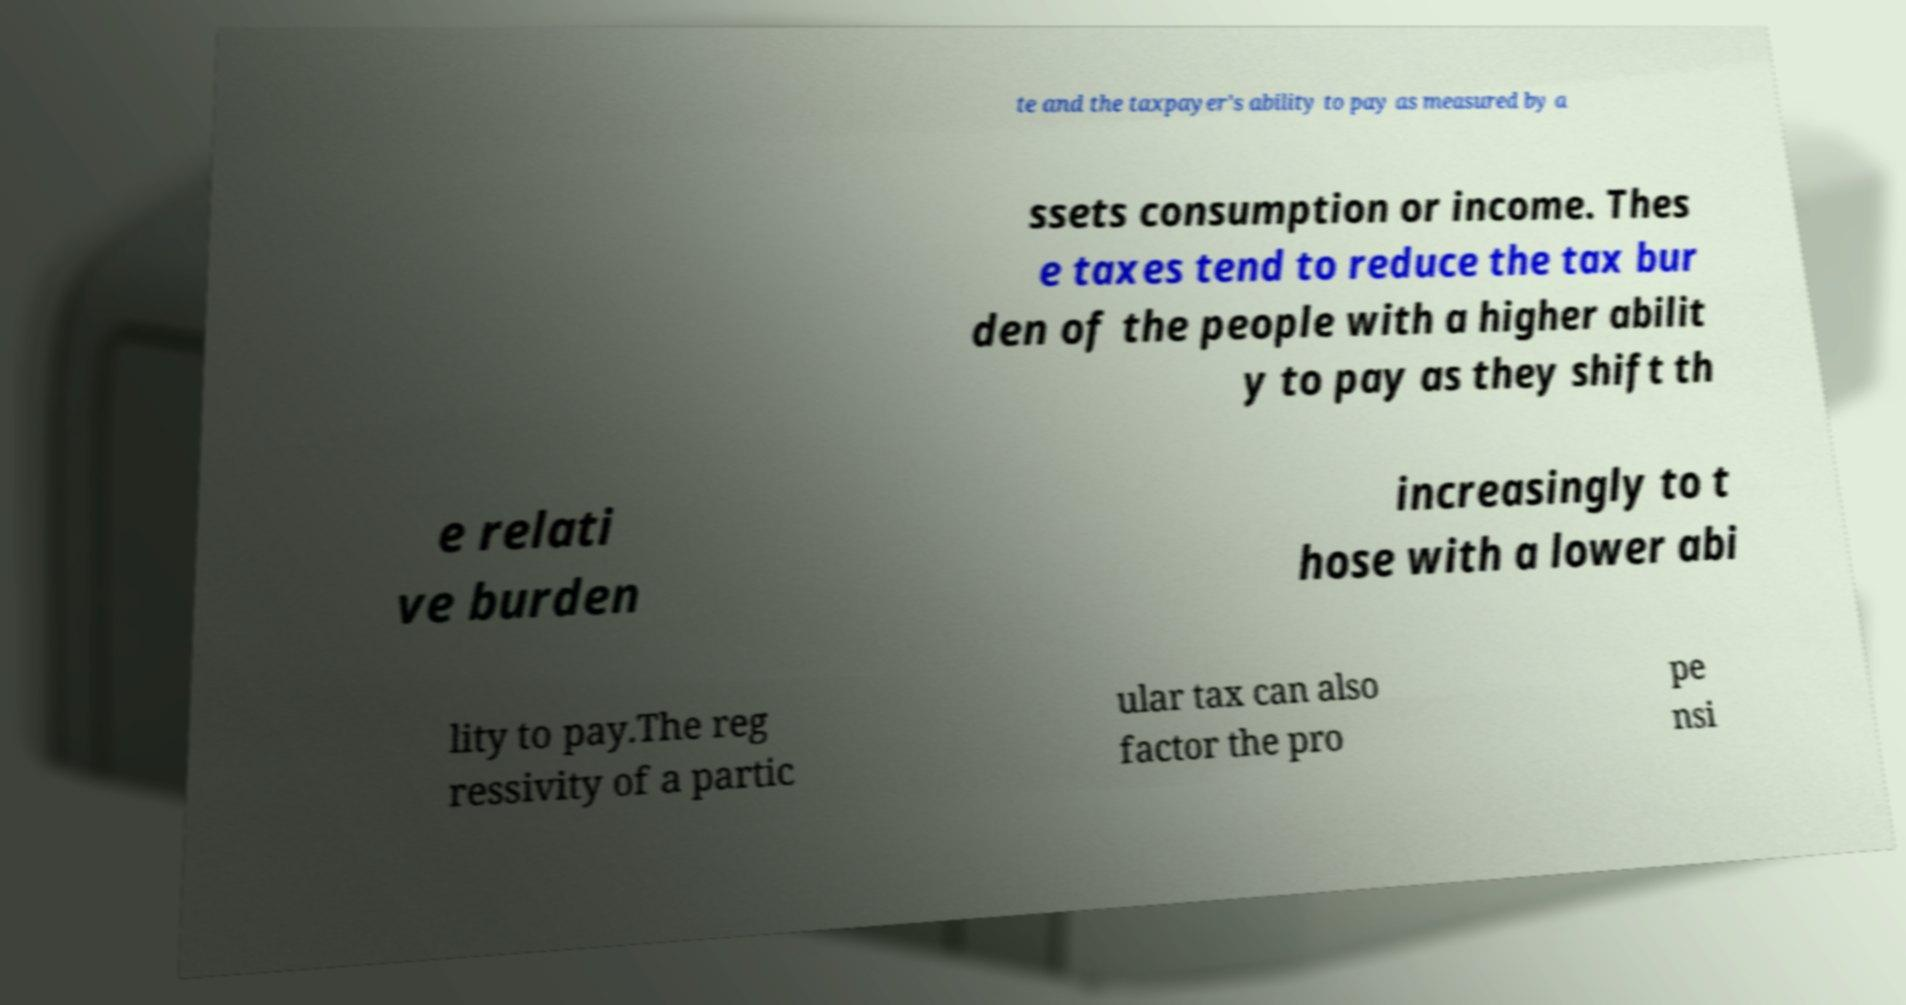There's text embedded in this image that I need extracted. Can you transcribe it verbatim? te and the taxpayer's ability to pay as measured by a ssets consumption or income. Thes e taxes tend to reduce the tax bur den of the people with a higher abilit y to pay as they shift th e relati ve burden increasingly to t hose with a lower abi lity to pay.The reg ressivity of a partic ular tax can also factor the pro pe nsi 